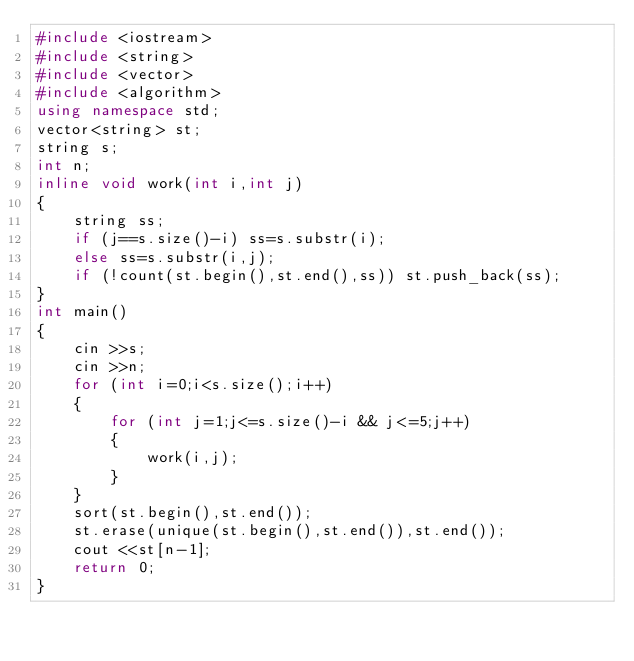Convert code to text. <code><loc_0><loc_0><loc_500><loc_500><_C++_>#include <iostream>
#include <string>
#include <vector>
#include <algorithm>
using namespace std;
vector<string> st;
string s;
int n;
inline void work(int i,int j)
{
	string ss;
	if (j==s.size()-i) ss=s.substr(i);
	else ss=s.substr(i,j);
	if (!count(st.begin(),st.end(),ss)) st.push_back(ss);
}
int main()
{
	cin >>s;
	cin >>n;
	for (int i=0;i<s.size();i++)
	{
		for (int j=1;j<=s.size()-i && j<=5;j++)
		{
			work(i,j);
		}
	}
	sort(st.begin(),st.end());
	st.erase(unique(st.begin(),st.end()),st.end());
	cout <<st[n-1];
	return 0;
} </code> 